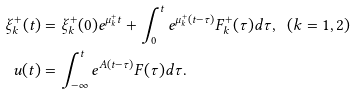<formula> <loc_0><loc_0><loc_500><loc_500>\xi ^ { + } _ { k } ( t ) & = \xi ^ { + } _ { k } ( 0 ) e ^ { \mu ^ { + } _ { k } t } + \int ^ { t } _ { 0 } e ^ { \mu ^ { + } _ { k } ( t - \tau ) } F ^ { + } _ { k } ( \tau ) d \tau , \ \ ( k = 1 , 2 ) \\ u ( t ) & = \int ^ { t } _ { - \infty } e ^ { A ( t - \tau ) } F ( \tau ) d \tau .</formula> 